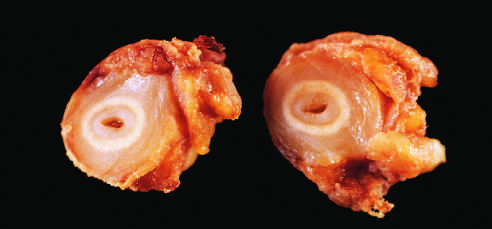what is shown in the figure demonstrating marked intimal thickening and luminal narrowing?
Answer the question using a single word or phrase. Cross-sections of right carotid artery from the patient 